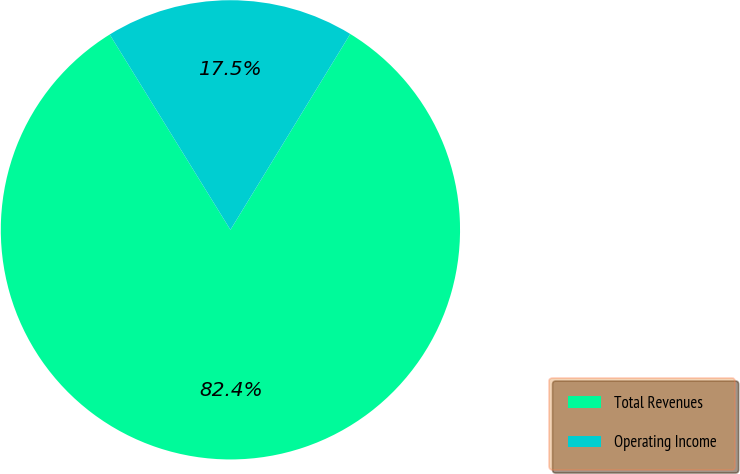<chart> <loc_0><loc_0><loc_500><loc_500><pie_chart><fcel>Total Revenues<fcel>Operating Income<nl><fcel>82.45%<fcel>17.55%<nl></chart> 